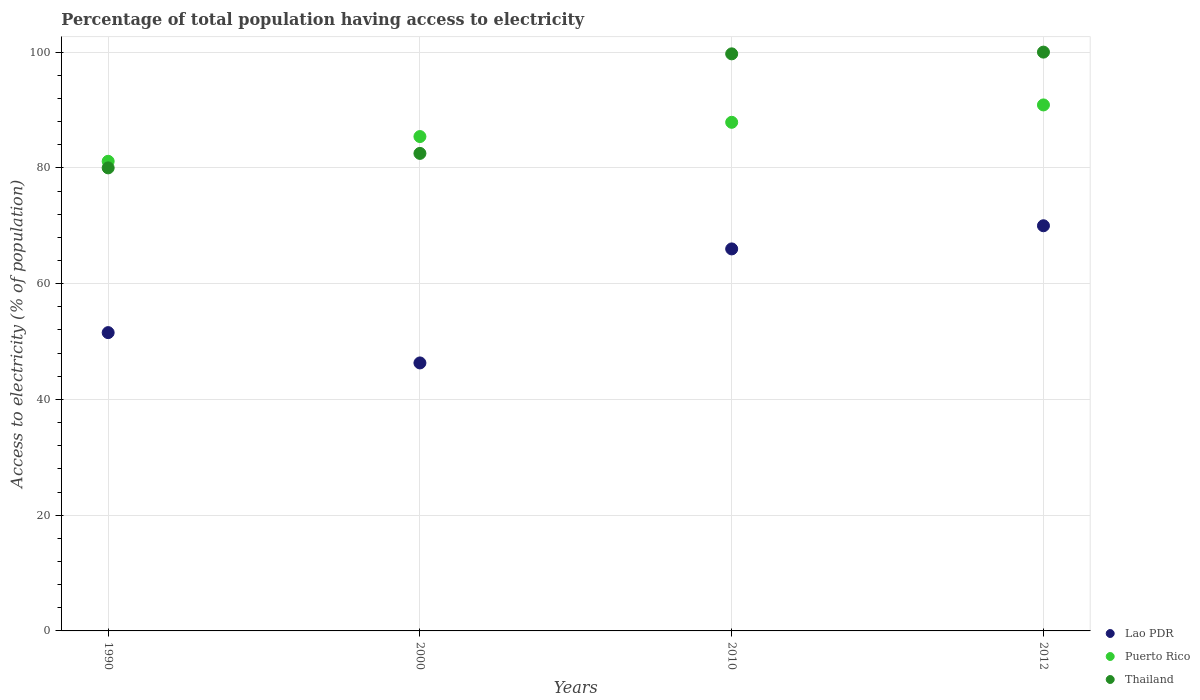How many different coloured dotlines are there?
Provide a short and direct response. 3. Is the number of dotlines equal to the number of legend labels?
Keep it short and to the point. Yes. What is the percentage of population that have access to electricity in Lao PDR in 2000?
Ensure brevity in your answer.  46.3. Across all years, what is the maximum percentage of population that have access to electricity in Puerto Rico?
Keep it short and to the point. 90.88. Across all years, what is the minimum percentage of population that have access to electricity in Lao PDR?
Make the answer very short. 46.3. In which year was the percentage of population that have access to electricity in Thailand minimum?
Ensure brevity in your answer.  1990. What is the total percentage of population that have access to electricity in Thailand in the graph?
Give a very brief answer. 362.2. What is the difference between the percentage of population that have access to electricity in Puerto Rico in 1990 and that in 2012?
Offer a very short reply. -9.74. What is the difference between the percentage of population that have access to electricity in Puerto Rico in 2000 and the percentage of population that have access to electricity in Thailand in 2010?
Provide a succinct answer. -14.29. What is the average percentage of population that have access to electricity in Lao PDR per year?
Keep it short and to the point. 58.46. In the year 2012, what is the difference between the percentage of population that have access to electricity in Puerto Rico and percentage of population that have access to electricity in Lao PDR?
Provide a succinct answer. 20.88. What is the ratio of the percentage of population that have access to electricity in Lao PDR in 1990 to that in 2000?
Your response must be concise. 1.11. Is the percentage of population that have access to electricity in Lao PDR in 1990 less than that in 2000?
Your response must be concise. No. What is the difference between the highest and the second highest percentage of population that have access to electricity in Puerto Rico?
Your response must be concise. 3. What is the difference between the highest and the lowest percentage of population that have access to electricity in Lao PDR?
Your answer should be very brief. 23.7. In how many years, is the percentage of population that have access to electricity in Thailand greater than the average percentage of population that have access to electricity in Thailand taken over all years?
Your answer should be very brief. 2. Is it the case that in every year, the sum of the percentage of population that have access to electricity in Thailand and percentage of population that have access to electricity in Lao PDR  is greater than the percentage of population that have access to electricity in Puerto Rico?
Offer a terse response. Yes. Is the percentage of population that have access to electricity in Puerto Rico strictly greater than the percentage of population that have access to electricity in Thailand over the years?
Your answer should be compact. No. How many dotlines are there?
Keep it short and to the point. 3. How many years are there in the graph?
Your answer should be very brief. 4. What is the difference between two consecutive major ticks on the Y-axis?
Make the answer very short. 20. Are the values on the major ticks of Y-axis written in scientific E-notation?
Your response must be concise. No. Does the graph contain grids?
Provide a short and direct response. Yes. What is the title of the graph?
Ensure brevity in your answer.  Percentage of total population having access to electricity. Does "Ecuador" appear as one of the legend labels in the graph?
Offer a very short reply. No. What is the label or title of the Y-axis?
Your answer should be compact. Access to electricity (% of population). What is the Access to electricity (% of population) in Lao PDR in 1990?
Your answer should be compact. 51.54. What is the Access to electricity (% of population) of Puerto Rico in 1990?
Your response must be concise. 81.14. What is the Access to electricity (% of population) in Thailand in 1990?
Ensure brevity in your answer.  80. What is the Access to electricity (% of population) in Lao PDR in 2000?
Your answer should be compact. 46.3. What is the Access to electricity (% of population) of Puerto Rico in 2000?
Your answer should be very brief. 85.41. What is the Access to electricity (% of population) of Thailand in 2000?
Offer a terse response. 82.5. What is the Access to electricity (% of population) in Puerto Rico in 2010?
Your answer should be very brief. 87.87. What is the Access to electricity (% of population) of Thailand in 2010?
Provide a short and direct response. 99.7. What is the Access to electricity (% of population) in Lao PDR in 2012?
Provide a short and direct response. 70. What is the Access to electricity (% of population) in Puerto Rico in 2012?
Ensure brevity in your answer.  90.88. What is the Access to electricity (% of population) in Thailand in 2012?
Your response must be concise. 100. Across all years, what is the maximum Access to electricity (% of population) in Puerto Rico?
Your answer should be very brief. 90.88. Across all years, what is the minimum Access to electricity (% of population) of Lao PDR?
Provide a short and direct response. 46.3. Across all years, what is the minimum Access to electricity (% of population) in Puerto Rico?
Give a very brief answer. 81.14. What is the total Access to electricity (% of population) of Lao PDR in the graph?
Your response must be concise. 233.84. What is the total Access to electricity (% of population) of Puerto Rico in the graph?
Provide a succinct answer. 345.3. What is the total Access to electricity (% of population) in Thailand in the graph?
Ensure brevity in your answer.  362.2. What is the difference between the Access to electricity (% of population) of Lao PDR in 1990 and that in 2000?
Offer a terse response. 5.24. What is the difference between the Access to electricity (% of population) in Puerto Rico in 1990 and that in 2000?
Offer a very short reply. -4.28. What is the difference between the Access to electricity (% of population) of Thailand in 1990 and that in 2000?
Provide a short and direct response. -2.5. What is the difference between the Access to electricity (% of population) of Lao PDR in 1990 and that in 2010?
Give a very brief answer. -14.46. What is the difference between the Access to electricity (% of population) of Puerto Rico in 1990 and that in 2010?
Offer a terse response. -6.74. What is the difference between the Access to electricity (% of population) in Thailand in 1990 and that in 2010?
Your answer should be compact. -19.7. What is the difference between the Access to electricity (% of population) in Lao PDR in 1990 and that in 2012?
Provide a short and direct response. -18.46. What is the difference between the Access to electricity (% of population) in Puerto Rico in 1990 and that in 2012?
Keep it short and to the point. -9.74. What is the difference between the Access to electricity (% of population) of Thailand in 1990 and that in 2012?
Ensure brevity in your answer.  -20. What is the difference between the Access to electricity (% of population) of Lao PDR in 2000 and that in 2010?
Your answer should be very brief. -19.7. What is the difference between the Access to electricity (% of population) of Puerto Rico in 2000 and that in 2010?
Offer a terse response. -2.46. What is the difference between the Access to electricity (% of population) of Thailand in 2000 and that in 2010?
Offer a very short reply. -17.2. What is the difference between the Access to electricity (% of population) of Lao PDR in 2000 and that in 2012?
Provide a short and direct response. -23.7. What is the difference between the Access to electricity (% of population) of Puerto Rico in 2000 and that in 2012?
Your answer should be very brief. -5.46. What is the difference between the Access to electricity (% of population) of Thailand in 2000 and that in 2012?
Your answer should be very brief. -17.5. What is the difference between the Access to electricity (% of population) in Puerto Rico in 2010 and that in 2012?
Ensure brevity in your answer.  -3. What is the difference between the Access to electricity (% of population) in Lao PDR in 1990 and the Access to electricity (% of population) in Puerto Rico in 2000?
Ensure brevity in your answer.  -33.87. What is the difference between the Access to electricity (% of population) of Lao PDR in 1990 and the Access to electricity (% of population) of Thailand in 2000?
Your answer should be very brief. -30.96. What is the difference between the Access to electricity (% of population) in Puerto Rico in 1990 and the Access to electricity (% of population) in Thailand in 2000?
Provide a succinct answer. -1.36. What is the difference between the Access to electricity (% of population) of Lao PDR in 1990 and the Access to electricity (% of population) of Puerto Rico in 2010?
Provide a succinct answer. -36.34. What is the difference between the Access to electricity (% of population) in Lao PDR in 1990 and the Access to electricity (% of population) in Thailand in 2010?
Your answer should be compact. -48.16. What is the difference between the Access to electricity (% of population) in Puerto Rico in 1990 and the Access to electricity (% of population) in Thailand in 2010?
Provide a succinct answer. -18.56. What is the difference between the Access to electricity (% of population) of Lao PDR in 1990 and the Access to electricity (% of population) of Puerto Rico in 2012?
Provide a short and direct response. -39.34. What is the difference between the Access to electricity (% of population) of Lao PDR in 1990 and the Access to electricity (% of population) of Thailand in 2012?
Your response must be concise. -48.46. What is the difference between the Access to electricity (% of population) of Puerto Rico in 1990 and the Access to electricity (% of population) of Thailand in 2012?
Your response must be concise. -18.86. What is the difference between the Access to electricity (% of population) of Lao PDR in 2000 and the Access to electricity (% of population) of Puerto Rico in 2010?
Give a very brief answer. -41.57. What is the difference between the Access to electricity (% of population) in Lao PDR in 2000 and the Access to electricity (% of population) in Thailand in 2010?
Make the answer very short. -53.4. What is the difference between the Access to electricity (% of population) of Puerto Rico in 2000 and the Access to electricity (% of population) of Thailand in 2010?
Ensure brevity in your answer.  -14.29. What is the difference between the Access to electricity (% of population) in Lao PDR in 2000 and the Access to electricity (% of population) in Puerto Rico in 2012?
Offer a very short reply. -44.58. What is the difference between the Access to electricity (% of population) of Lao PDR in 2000 and the Access to electricity (% of population) of Thailand in 2012?
Your response must be concise. -53.7. What is the difference between the Access to electricity (% of population) in Puerto Rico in 2000 and the Access to electricity (% of population) in Thailand in 2012?
Your answer should be compact. -14.59. What is the difference between the Access to electricity (% of population) in Lao PDR in 2010 and the Access to electricity (% of population) in Puerto Rico in 2012?
Your response must be concise. -24.88. What is the difference between the Access to electricity (% of population) in Lao PDR in 2010 and the Access to electricity (% of population) in Thailand in 2012?
Provide a short and direct response. -34. What is the difference between the Access to electricity (% of population) in Puerto Rico in 2010 and the Access to electricity (% of population) in Thailand in 2012?
Offer a terse response. -12.13. What is the average Access to electricity (% of population) of Lao PDR per year?
Provide a succinct answer. 58.46. What is the average Access to electricity (% of population) of Puerto Rico per year?
Offer a terse response. 86.32. What is the average Access to electricity (% of population) of Thailand per year?
Provide a short and direct response. 90.55. In the year 1990, what is the difference between the Access to electricity (% of population) of Lao PDR and Access to electricity (% of population) of Puerto Rico?
Provide a short and direct response. -29.6. In the year 1990, what is the difference between the Access to electricity (% of population) in Lao PDR and Access to electricity (% of population) in Thailand?
Provide a short and direct response. -28.46. In the year 1990, what is the difference between the Access to electricity (% of population) in Puerto Rico and Access to electricity (% of population) in Thailand?
Your answer should be very brief. 1.14. In the year 2000, what is the difference between the Access to electricity (% of population) of Lao PDR and Access to electricity (% of population) of Puerto Rico?
Offer a very short reply. -39.11. In the year 2000, what is the difference between the Access to electricity (% of population) in Lao PDR and Access to electricity (% of population) in Thailand?
Ensure brevity in your answer.  -36.2. In the year 2000, what is the difference between the Access to electricity (% of population) of Puerto Rico and Access to electricity (% of population) of Thailand?
Keep it short and to the point. 2.91. In the year 2010, what is the difference between the Access to electricity (% of population) in Lao PDR and Access to electricity (% of population) in Puerto Rico?
Ensure brevity in your answer.  -21.87. In the year 2010, what is the difference between the Access to electricity (% of population) in Lao PDR and Access to electricity (% of population) in Thailand?
Your answer should be very brief. -33.7. In the year 2010, what is the difference between the Access to electricity (% of population) of Puerto Rico and Access to electricity (% of population) of Thailand?
Provide a succinct answer. -11.83. In the year 2012, what is the difference between the Access to electricity (% of population) of Lao PDR and Access to electricity (% of population) of Puerto Rico?
Make the answer very short. -20.88. In the year 2012, what is the difference between the Access to electricity (% of population) of Puerto Rico and Access to electricity (% of population) of Thailand?
Your response must be concise. -9.12. What is the ratio of the Access to electricity (% of population) in Lao PDR in 1990 to that in 2000?
Give a very brief answer. 1.11. What is the ratio of the Access to electricity (% of population) of Puerto Rico in 1990 to that in 2000?
Offer a very short reply. 0.95. What is the ratio of the Access to electricity (% of population) in Thailand in 1990 to that in 2000?
Give a very brief answer. 0.97. What is the ratio of the Access to electricity (% of population) in Lao PDR in 1990 to that in 2010?
Your response must be concise. 0.78. What is the ratio of the Access to electricity (% of population) in Puerto Rico in 1990 to that in 2010?
Provide a short and direct response. 0.92. What is the ratio of the Access to electricity (% of population) of Thailand in 1990 to that in 2010?
Make the answer very short. 0.8. What is the ratio of the Access to electricity (% of population) of Lao PDR in 1990 to that in 2012?
Give a very brief answer. 0.74. What is the ratio of the Access to electricity (% of population) of Puerto Rico in 1990 to that in 2012?
Your answer should be very brief. 0.89. What is the ratio of the Access to electricity (% of population) in Lao PDR in 2000 to that in 2010?
Ensure brevity in your answer.  0.7. What is the ratio of the Access to electricity (% of population) in Puerto Rico in 2000 to that in 2010?
Make the answer very short. 0.97. What is the ratio of the Access to electricity (% of population) in Thailand in 2000 to that in 2010?
Provide a succinct answer. 0.83. What is the ratio of the Access to electricity (% of population) of Lao PDR in 2000 to that in 2012?
Provide a succinct answer. 0.66. What is the ratio of the Access to electricity (% of population) in Puerto Rico in 2000 to that in 2012?
Offer a terse response. 0.94. What is the ratio of the Access to electricity (% of population) in Thailand in 2000 to that in 2012?
Your answer should be compact. 0.82. What is the ratio of the Access to electricity (% of population) in Lao PDR in 2010 to that in 2012?
Give a very brief answer. 0.94. What is the ratio of the Access to electricity (% of population) of Puerto Rico in 2010 to that in 2012?
Keep it short and to the point. 0.97. What is the ratio of the Access to electricity (% of population) of Thailand in 2010 to that in 2012?
Offer a very short reply. 1. What is the difference between the highest and the second highest Access to electricity (% of population) of Lao PDR?
Give a very brief answer. 4. What is the difference between the highest and the second highest Access to electricity (% of population) of Puerto Rico?
Make the answer very short. 3. What is the difference between the highest and the second highest Access to electricity (% of population) of Thailand?
Give a very brief answer. 0.3. What is the difference between the highest and the lowest Access to electricity (% of population) in Lao PDR?
Offer a very short reply. 23.7. What is the difference between the highest and the lowest Access to electricity (% of population) in Puerto Rico?
Keep it short and to the point. 9.74. What is the difference between the highest and the lowest Access to electricity (% of population) of Thailand?
Provide a short and direct response. 20. 